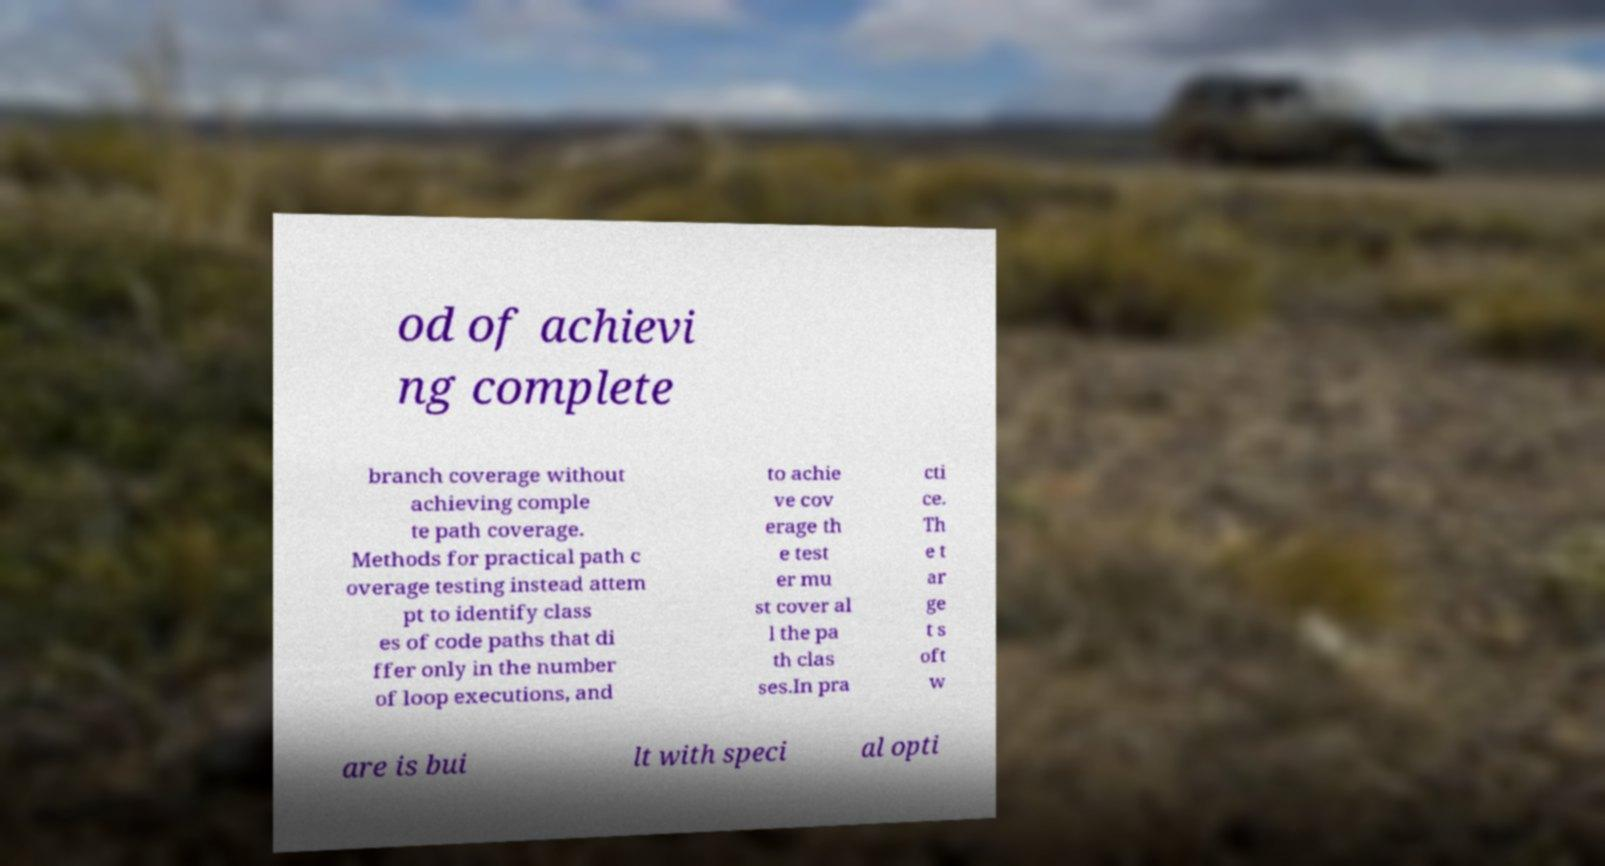Please read and relay the text visible in this image. What does it say? od of achievi ng complete branch coverage without achieving comple te path coverage. Methods for practical path c overage testing instead attem pt to identify class es of code paths that di ffer only in the number of loop executions, and to achie ve cov erage th e test er mu st cover al l the pa th clas ses.In pra cti ce. Th e t ar ge t s oft w are is bui lt with speci al opti 